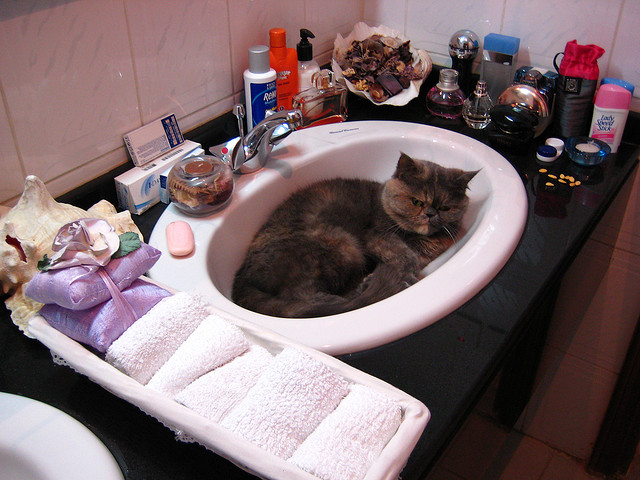Does the cat look happy? The cat's expression seems more relaxed than happy, with half-closed eyes and a calm posture typically associated with contentment rather than overt happiness. 